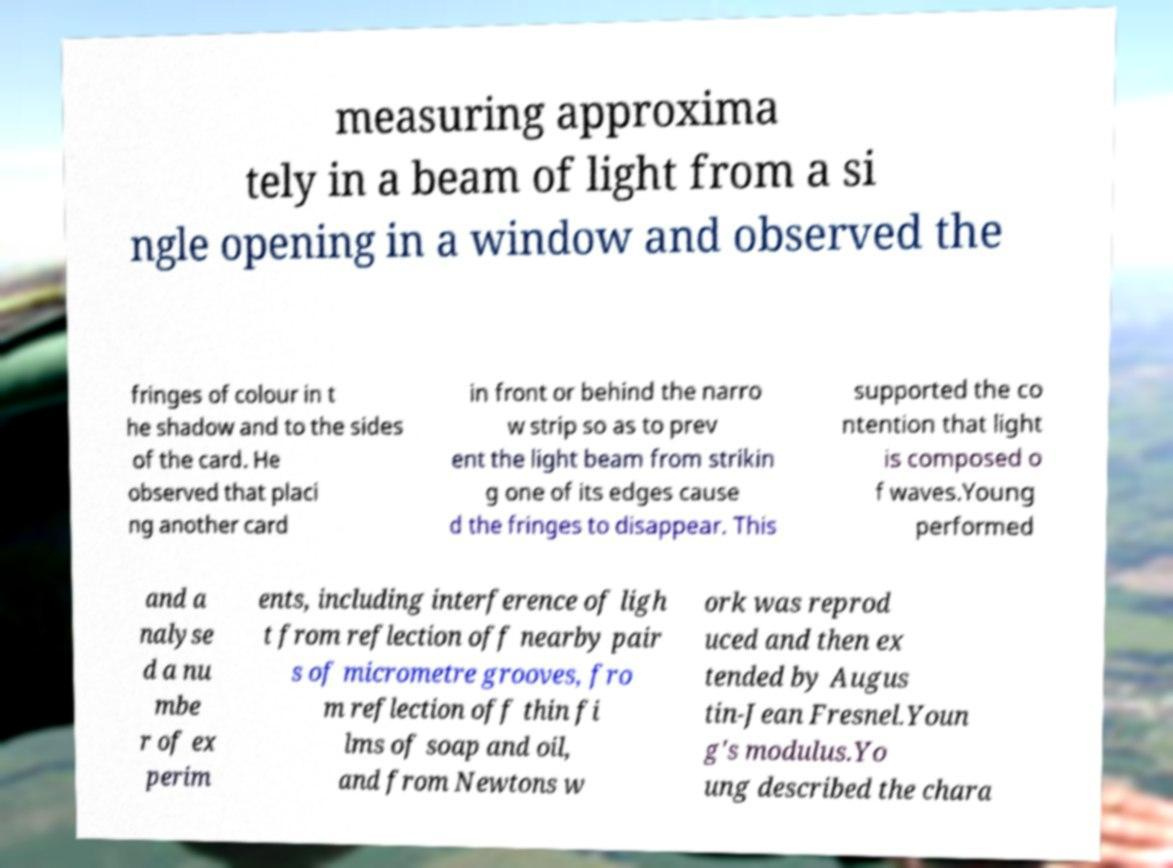Could you assist in decoding the text presented in this image and type it out clearly? measuring approxima tely in a beam of light from a si ngle opening in a window and observed the fringes of colour in t he shadow and to the sides of the card. He observed that placi ng another card in front or behind the narro w strip so as to prev ent the light beam from strikin g one of its edges cause d the fringes to disappear. This supported the co ntention that light is composed o f waves.Young performed and a nalyse d a nu mbe r of ex perim ents, including interference of ligh t from reflection off nearby pair s of micrometre grooves, fro m reflection off thin fi lms of soap and oil, and from Newtons w ork was reprod uced and then ex tended by Augus tin-Jean Fresnel.Youn g's modulus.Yo ung described the chara 